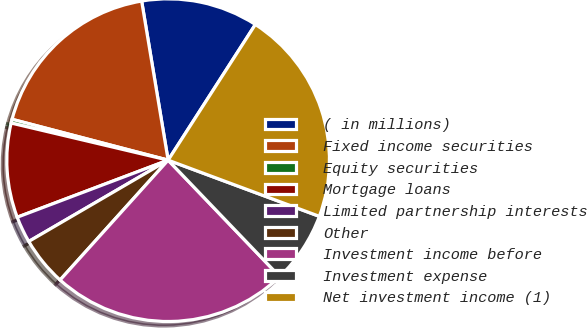<chart> <loc_0><loc_0><loc_500><loc_500><pie_chart><fcel>( in millions)<fcel>Fixed income securities<fcel>Equity securities<fcel>Mortgage loans<fcel>Limited partnership interests<fcel>Other<fcel>Investment income before<fcel>Investment expense<fcel>Net investment income (1)<nl><fcel>11.72%<fcel>18.3%<fcel>0.38%<fcel>9.45%<fcel>2.65%<fcel>4.92%<fcel>23.84%<fcel>7.18%<fcel>21.57%<nl></chart> 